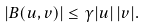<formula> <loc_0><loc_0><loc_500><loc_500>| B ( u , v ) | \leq \gamma | u | \, | v | .</formula> 